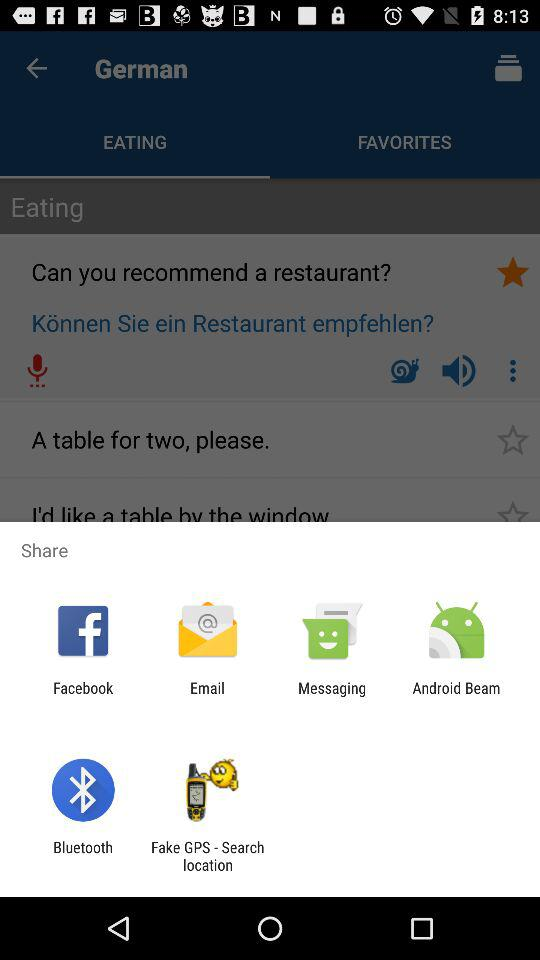Which tab is selected? The selected tab is "EATING". 